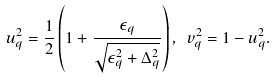<formula> <loc_0><loc_0><loc_500><loc_500>u _ { q } ^ { 2 } = \frac { 1 } { 2 } \left ( 1 + \frac { \epsilon _ { q } } { \sqrt { \epsilon _ { q } ^ { 2 } + \Delta _ { q } ^ { 2 } } } \right ) , \ v _ { q } ^ { 2 } = 1 - u ^ { 2 } _ { q } .</formula> 